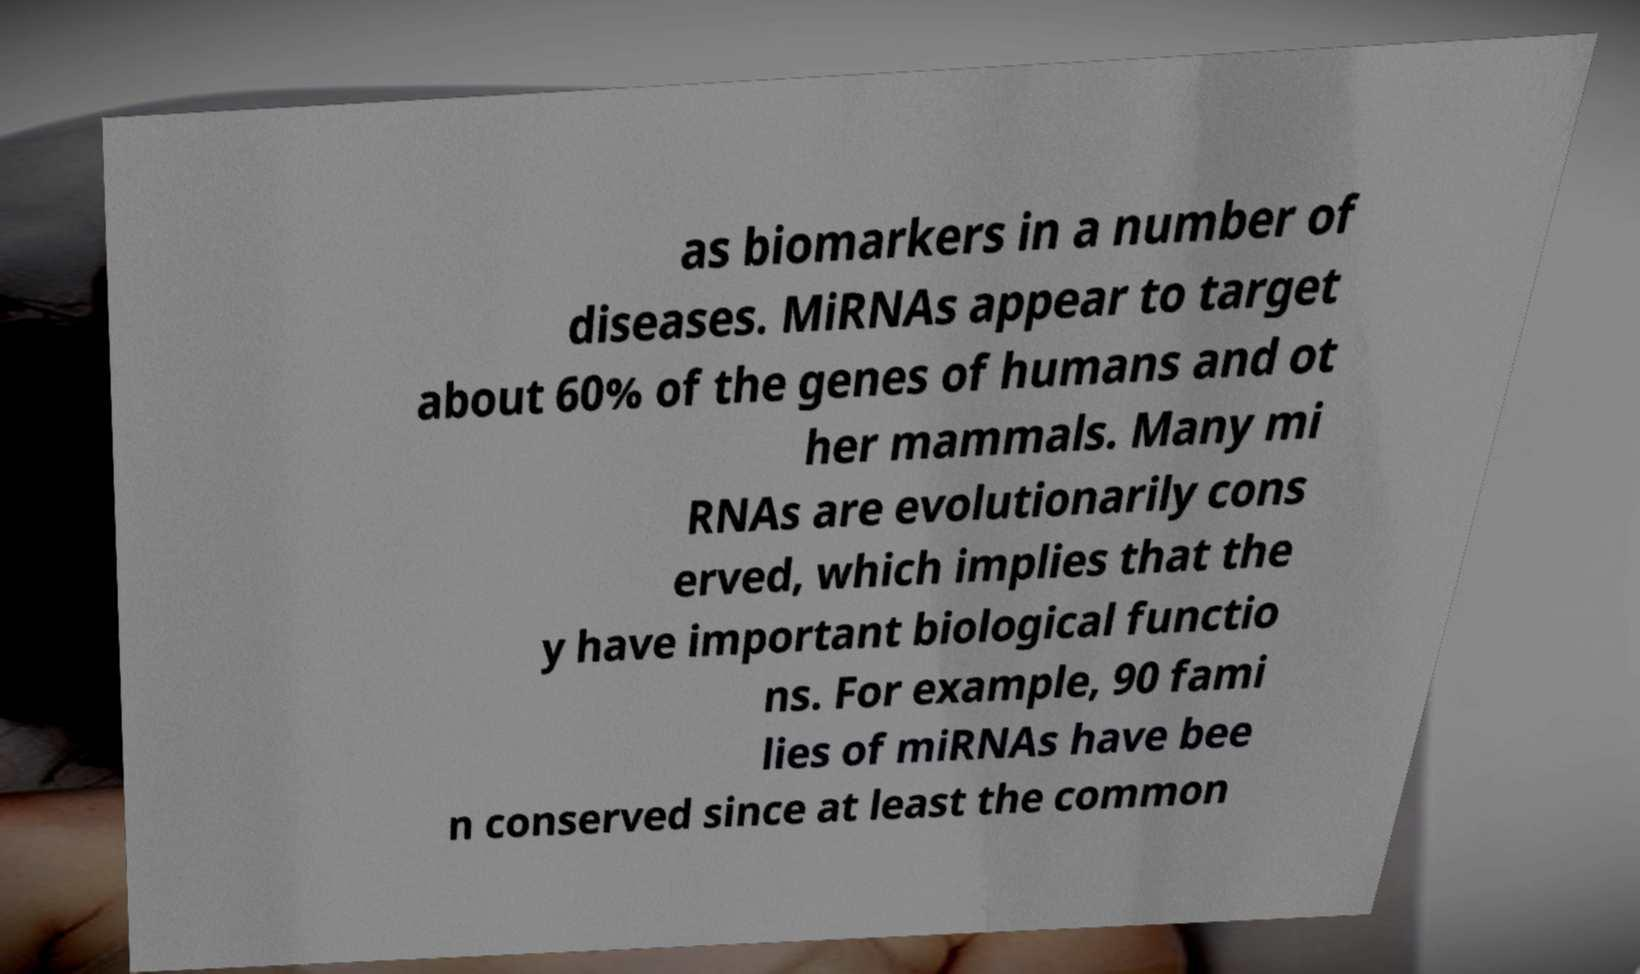Can you accurately transcribe the text from the provided image for me? as biomarkers in a number of diseases. MiRNAs appear to target about 60% of the genes of humans and ot her mammals. Many mi RNAs are evolutionarily cons erved, which implies that the y have important biological functio ns. For example, 90 fami lies of miRNAs have bee n conserved since at least the common 